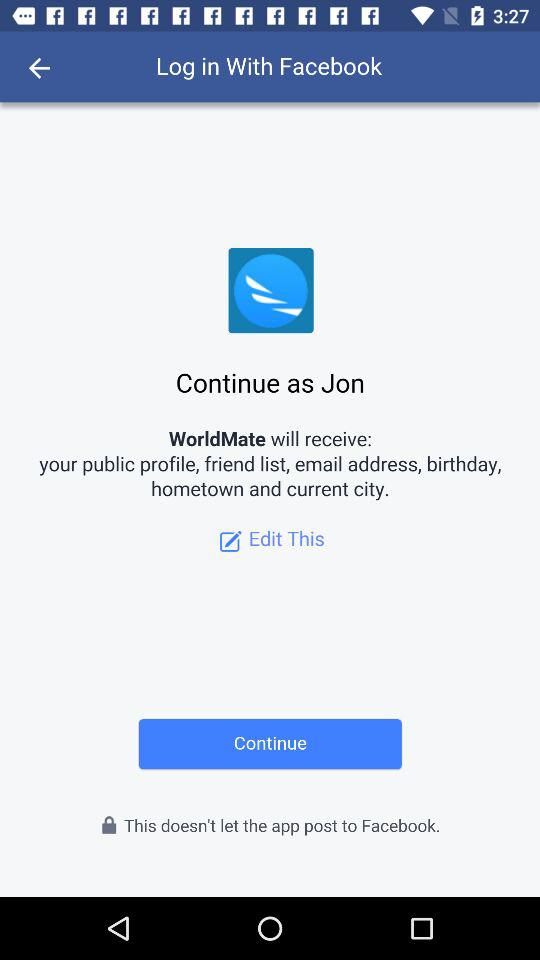What is the login name? The login name is Jon. 